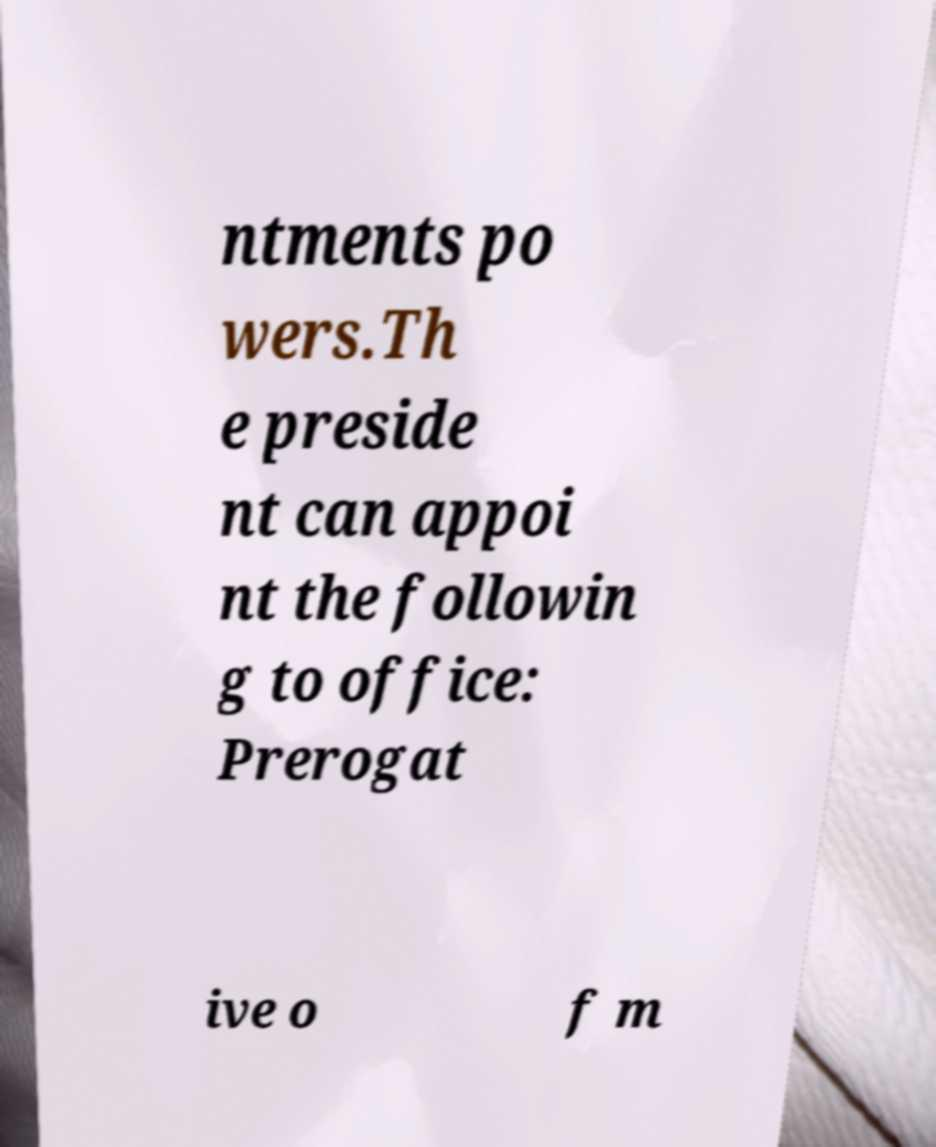Please identify and transcribe the text found in this image. ntments po wers.Th e preside nt can appoi nt the followin g to office: Prerogat ive o f m 